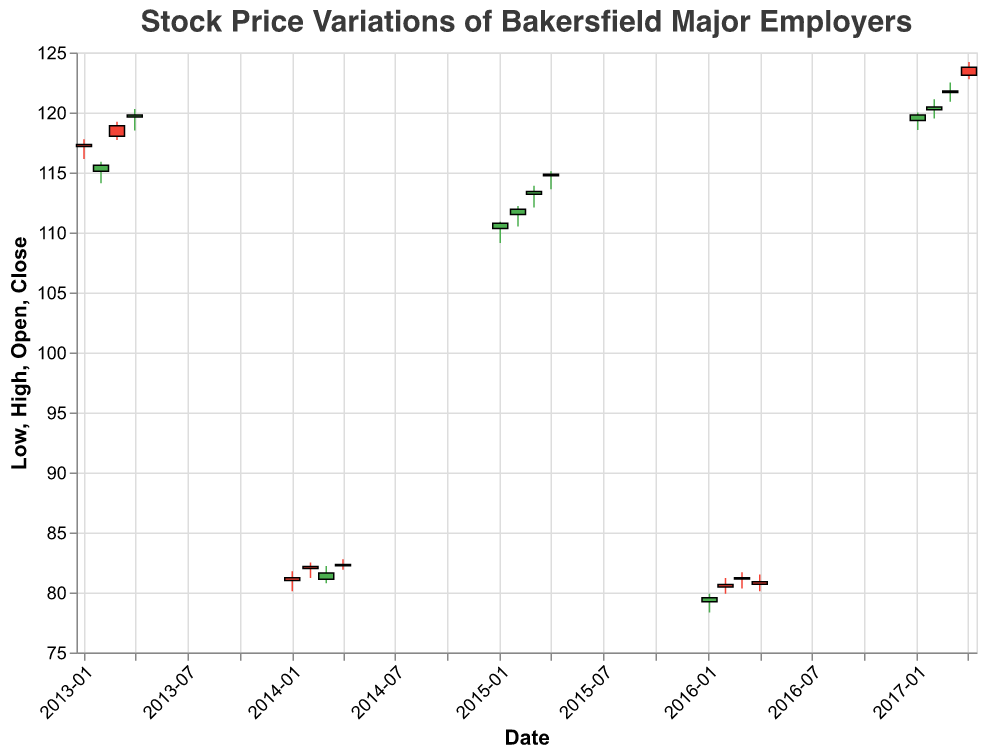What's the title of the figure? The title of the figure is "Stock Price Variations of Bakersfield Major Employers," which is located at the top of the plot.
Answer: Stock Price Variations of Bakersfield Major Employers Which company had a higher stock price on January 2, 2013, Chevron or Grimmway Farms? On January 2, 2013, only Chevron has data, with an opening price of 117.34. Grimmway Farms does not have data for this date in the figure.
Answer: Chevron What was the highest stock price achieved by Grimmway Farms in 2014? The highest stock price achieved by Grimmway Farms in 2014 was 82.78, which occurred in April 2014.
Answer: 82.78 Did Chevron's stock price increase or decrease from January to February 2013? Chevron's stock price decreased from January to February 2013. It opened at 117.34 in January and closed at 115.60 in February.
Answer: Decrease What is the average closing price of Chevron's stock in the first quarter of 2017? To find the average, add the closing prices for January (119.79), February (120.45), and March (121.80) and divide by 3. The sum is 119.79 + 120.45 + 121.80 = 362.04. The average is 362.04 / 3 = 120.68.
Answer: 120.68 How did Grimmway Farms' stock price in January 2016 compare to its stock price in January 2014? Grimmway Farms' stock price in January 2016 had an opening of 79.23, whereas in January 2014, it had an opening of 81.23. This shows a decrease.
Answer: Decrease What was the lowest stock price recorded by Chevron in 2017? The lowest stock price recorded by Chevron in 2017 was 118.54, which occurred in January 2017.
Answer: 118.54 Which company had a higher trading volume, Chevron in March 2015 or Grimmway Farms in March 2016? Chevron had a higher trading volume in March 2015 with 2,045,600 shares compared to Grimmway Farms with 780,400 shares in March 2016.
Answer: Chevron Compare Chevron's stock closing prices between April 2013 and April 2017. Which year had a higher closing price? In April 2013, Chevron's closing price was 119.80. In April 2017, the closing price was 123.10. Therefore, April 2017 had a higher closing price.
Answer: April 2017 What trend can you observe in Chevron's stock prices from January to April 2017? Chevron's stock prices show an upward trend from January to April 2017, with prices moving from 119.79 in January to 123.10 in April.
Answer: Upward trend 